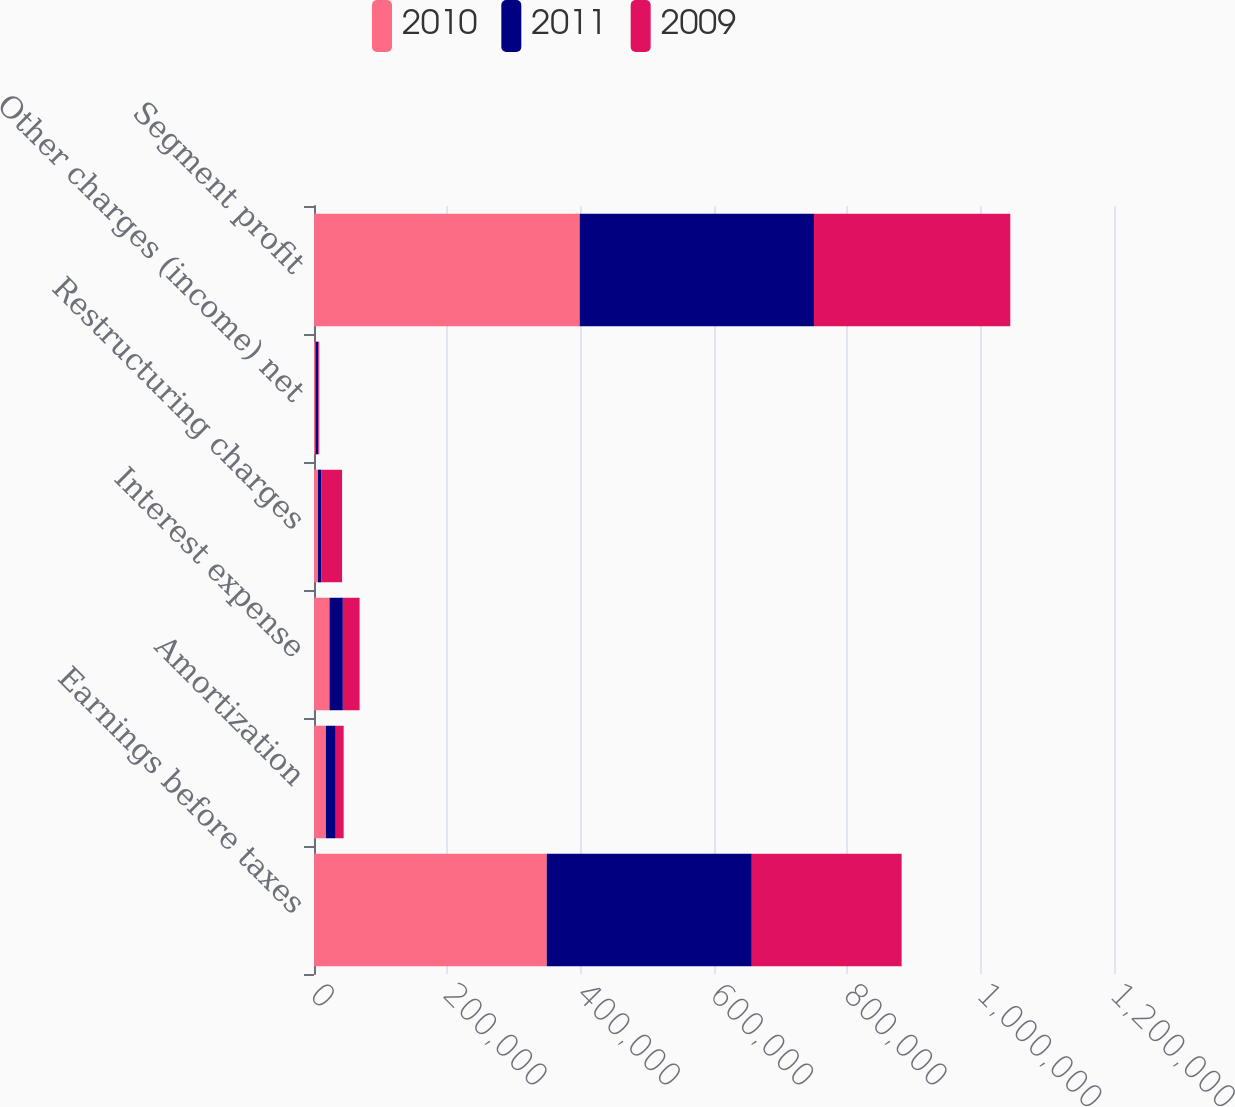Convert chart to OTSL. <chart><loc_0><loc_0><loc_500><loc_500><stacked_bar_chart><ecel><fcel>Earnings before taxes<fcel>Amortization<fcel>Interest expense<fcel>Restructuring charges<fcel>Other charges (income) net<fcel>Segment profit<nl><fcel>2010<fcel>349177<fcel>17808<fcel>23226<fcel>5912<fcel>2380<fcel>398503<nl><fcel>2011<fcel>307513<fcel>14842<fcel>20057<fcel>4866<fcel>4164<fcel>351442<nl><fcel>2009<fcel>224762<fcel>11844<fcel>25117<fcel>31368<fcel>1384<fcel>294475<nl></chart> 